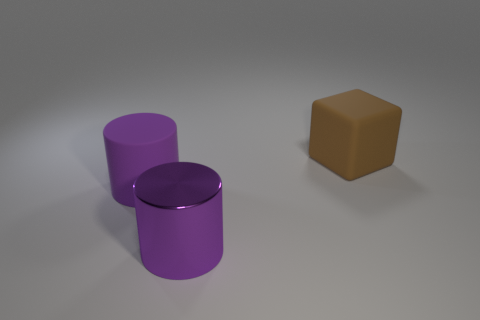Are there any other things that have the same shape as the brown object?
Keep it short and to the point. No. Is there a matte cylinder that is on the left side of the large thing that is behind the large matte object that is on the left side of the big block?
Keep it short and to the point. Yes. What is the shape of the purple metallic thing?
Your answer should be very brief. Cylinder. Does the object that is behind the rubber cylinder have the same material as the large purple cylinder that is behind the big purple metal cylinder?
Provide a succinct answer. Yes. How many large rubber objects have the same color as the large metal cylinder?
Make the answer very short. 1. There is a object that is both on the right side of the purple rubber cylinder and in front of the brown matte thing; what is its shape?
Your answer should be compact. Cylinder. What is the color of the object that is right of the large purple rubber object and behind the purple metal cylinder?
Your response must be concise. Brown. Are there more large objects that are in front of the brown block than brown things in front of the big purple rubber object?
Make the answer very short. Yes. The rubber object to the left of the purple metallic thing is what color?
Give a very brief answer. Purple. Do the big purple object on the right side of the big purple matte object and the object right of the metal object have the same shape?
Give a very brief answer. No. 